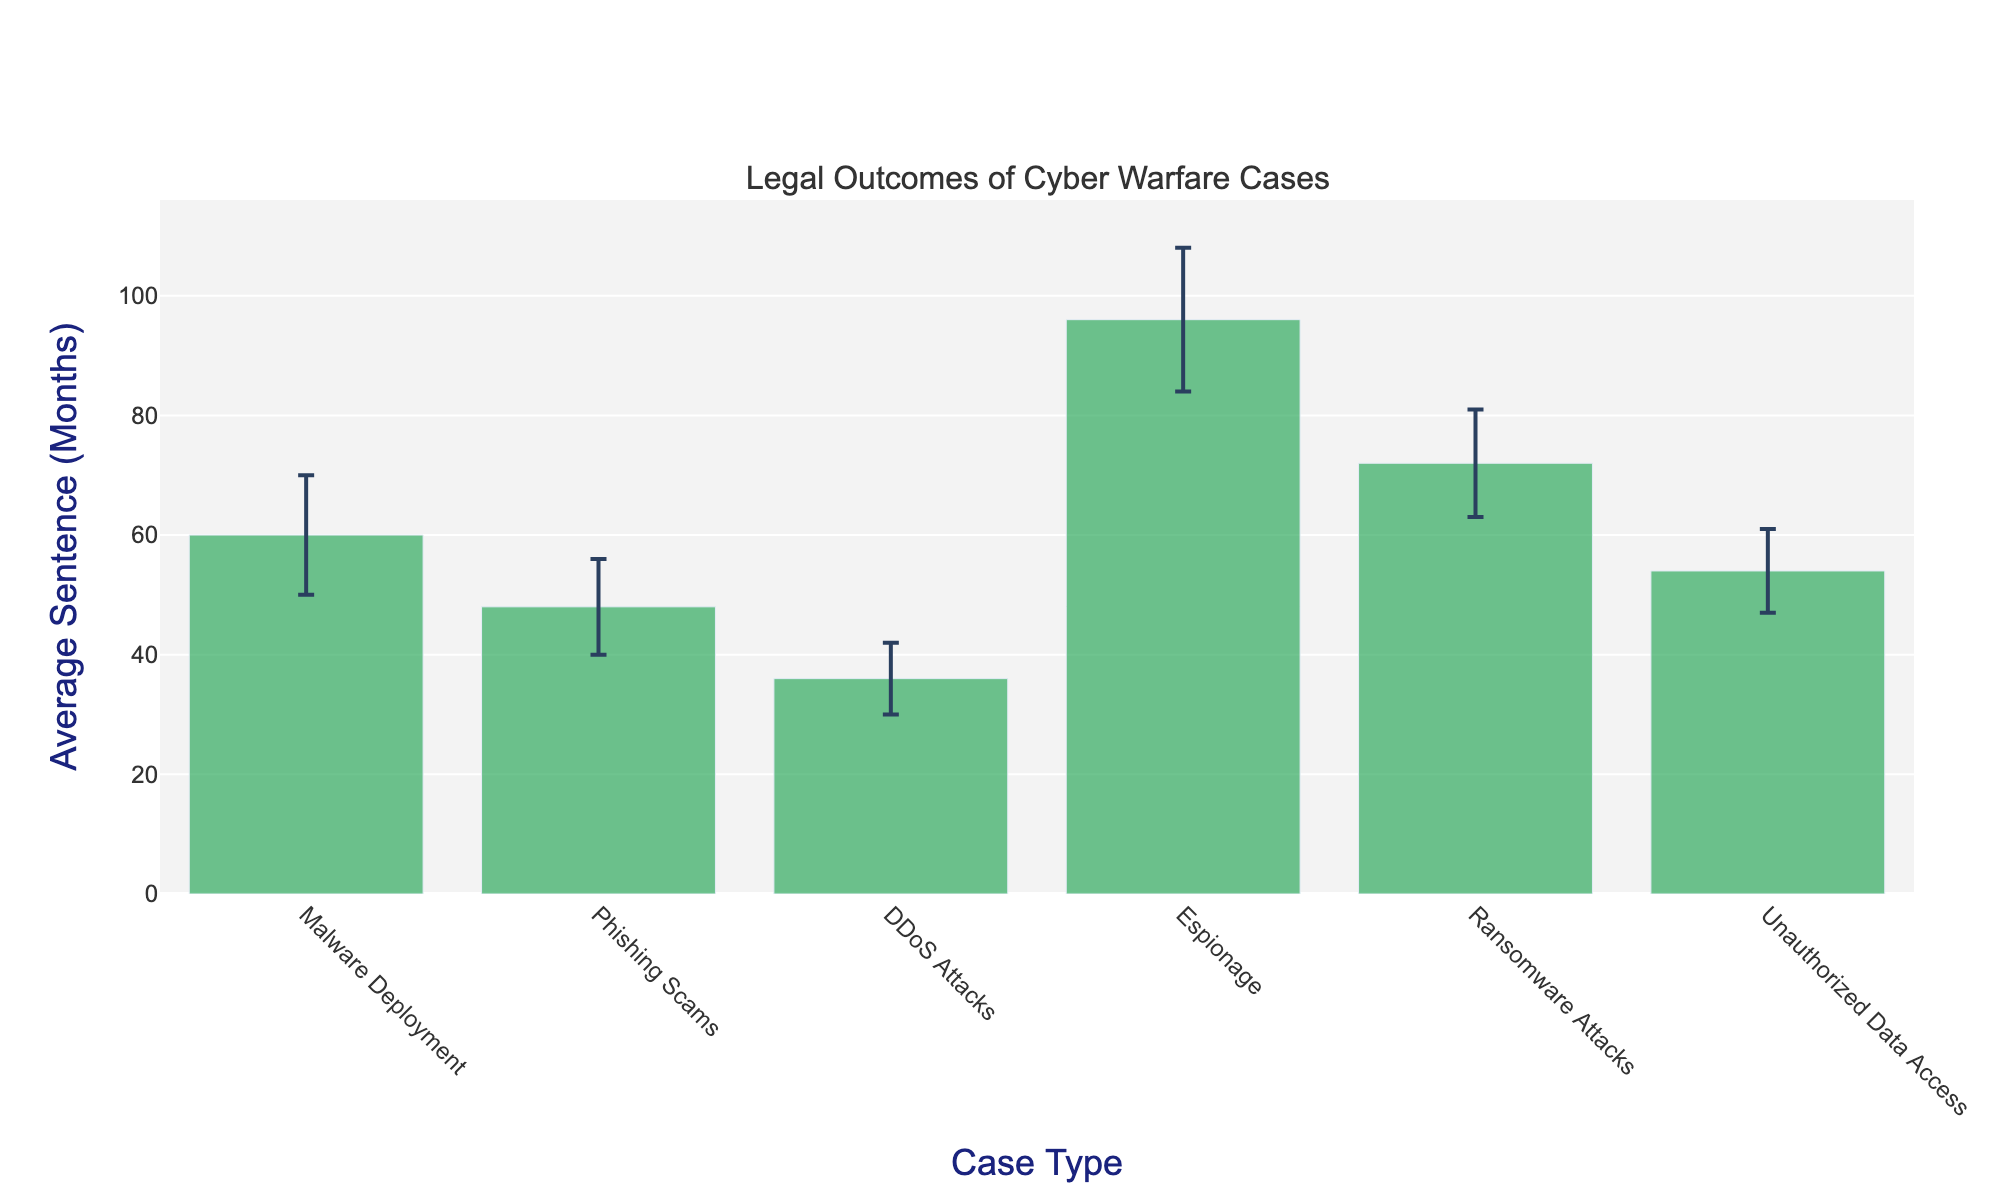What's the title of the chart? The title is displayed at the top of the chart. Look at the text prominently highlighted in a larger font size compared to the rest.
Answer: Legal Outcomes of Cyber Warfare Cases What is the average sentence for espionage? Find the bar labeled "Espionage" on the x-axis. The value on the y-axis corresponding to it shows the average sentence in months.
Answer: 96 months Which case type has the lowest average sentence? Identify the shortest bar on the chart. The label of this bar on the x-axis is the case type with the lowest average sentence.
Answer: DDoS Attacks What is the difference in average sentence between ransomware attacks and phishing scams? Locate the bars for "Ransomware Attacks" and "Phishing Scams" on the chart. Subtract the average sentence for "Phishing Scams" from that of "Ransomware Attacks".
Answer: 24 months Among the case types, which has the highest error margin? Look for the bar with the largest error bar (the vertical line extending from the top of the bar). Check the label on the x-axis for this bar.
Answer: Espionage What is the range of sentences for unauthorized data access? Identify the bar for "Unauthorized Data Access". The range is from the average sentence minus the error margin to the average sentence plus the error margin. Calculate the lower bound as 54 - 7 and the upper bound as 54 + 7.
Answer: 47 to 61 months How much higher is the average sentence for malware deployment compared to DDoS attacks? Locate the bars for "Malware Deployment" and "DDoS Attacks". Subtract the average sentence for "DDoS Attacks" from that of "Malware Deployment".
Answer: 24 months Which are the case types with an average sentence greater than 60 months? Examine the y-axis values for each bar. Identify the bars where the top of the bar is above the 60-month mark. Note the corresponding labels on the x-axis.
Answer: Espionage, Ransomware Attacks, Malware Deployment 